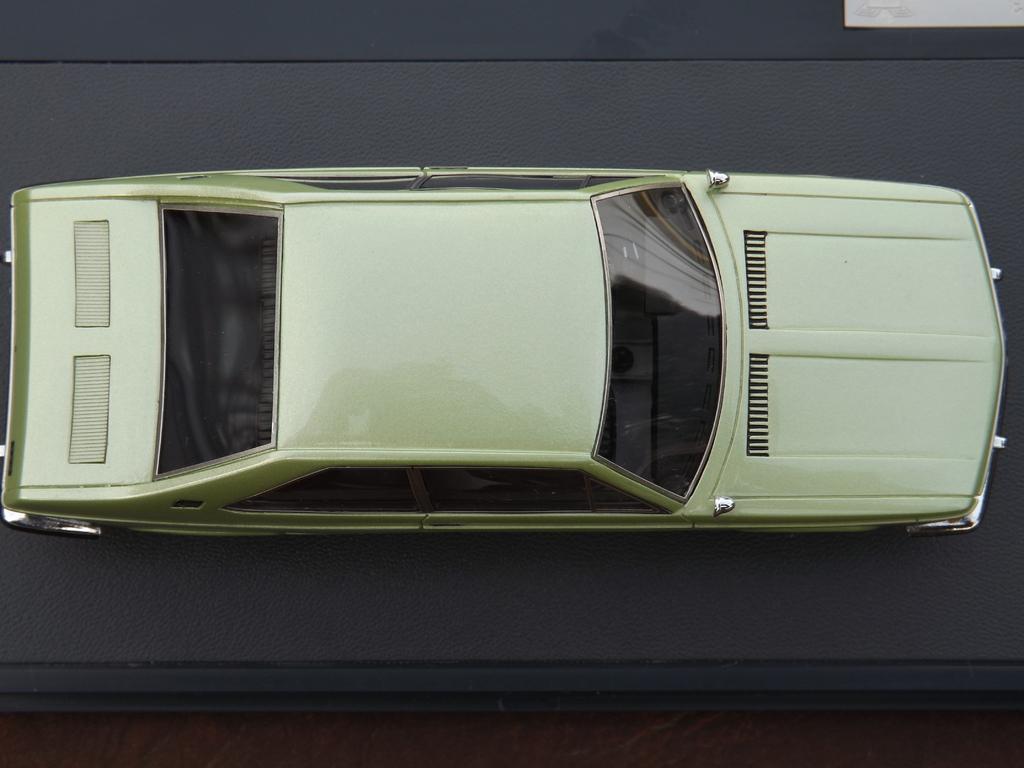Can you describe this image briefly? In this image I can see the car in cream color and the car is on the gray color surface. 